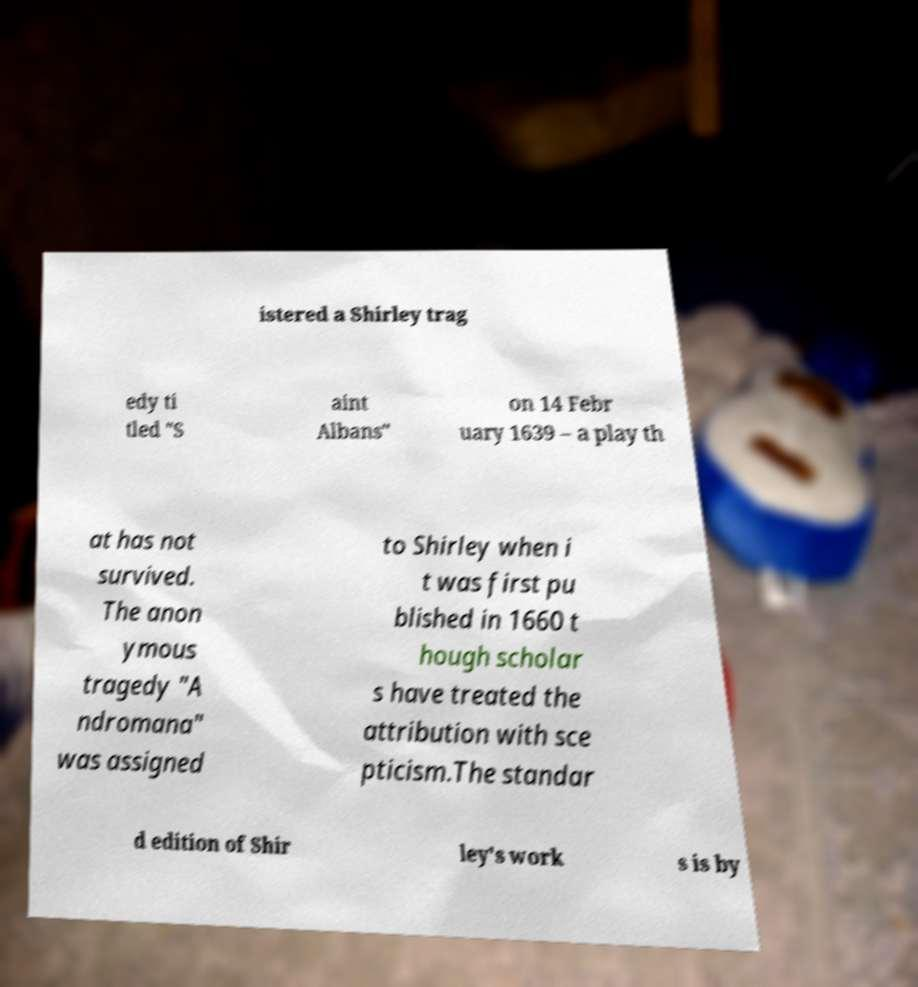What messages or text are displayed in this image? I need them in a readable, typed format. istered a Shirley trag edy ti tled "S aint Albans" on 14 Febr uary 1639 – a play th at has not survived. The anon ymous tragedy "A ndromana" was assigned to Shirley when i t was first pu blished in 1660 t hough scholar s have treated the attribution with sce pticism.The standar d edition of Shir ley's work s is by 